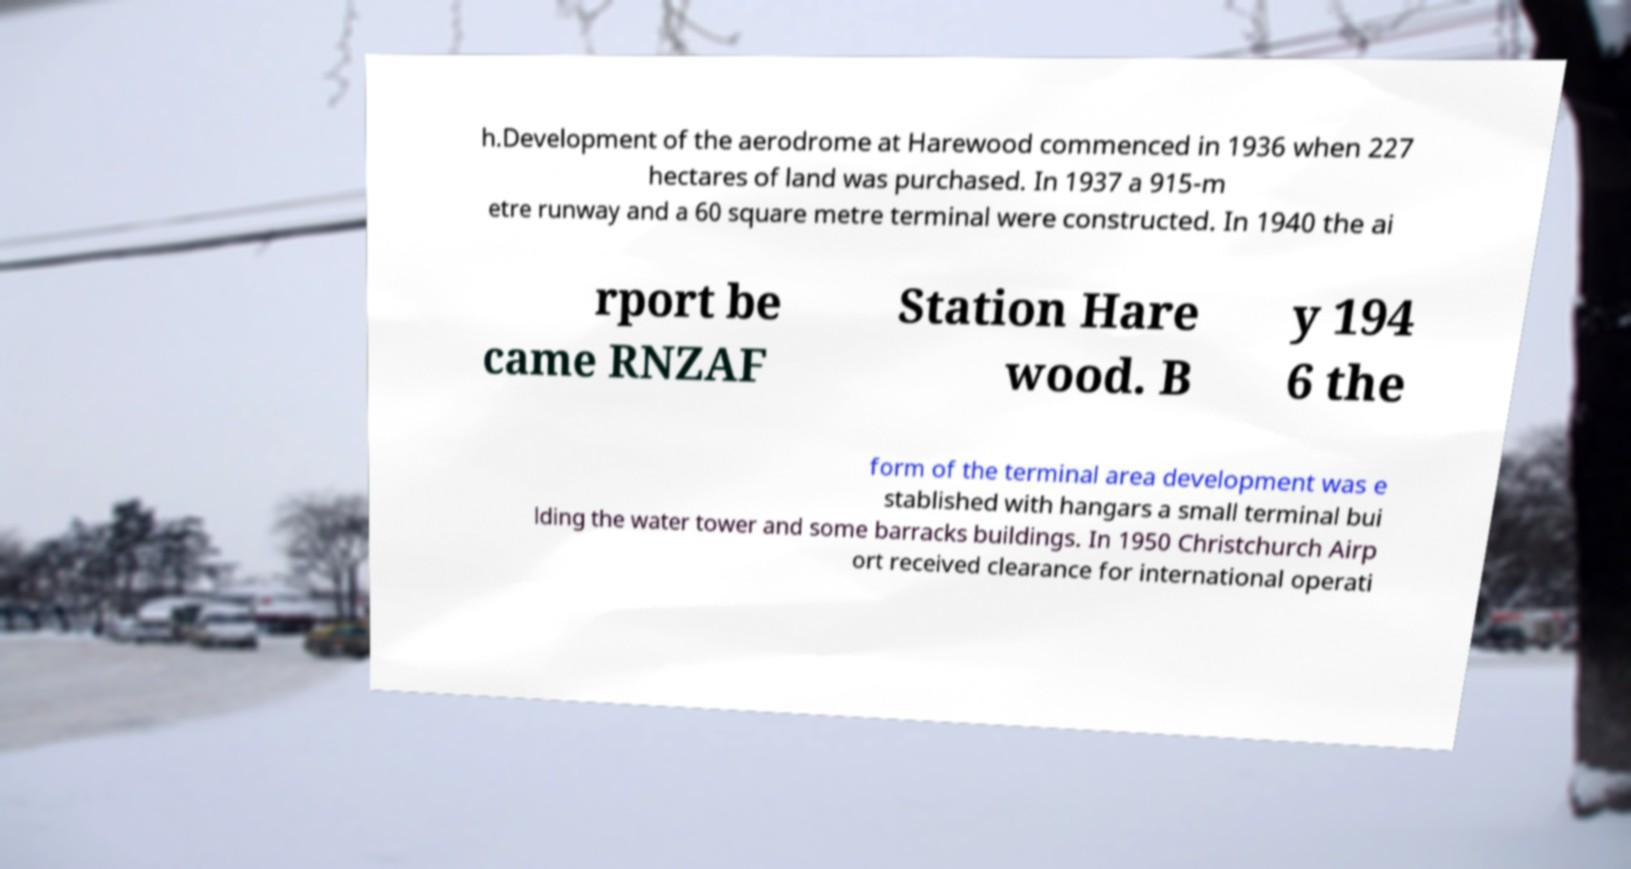Could you extract and type out the text from this image? h.Development of the aerodrome at Harewood commenced in 1936 when 227 hectares of land was purchased. In 1937 a 915-m etre runway and a 60 square metre terminal were constructed. In 1940 the ai rport be came RNZAF Station Hare wood. B y 194 6 the form of the terminal area development was e stablished with hangars a small terminal bui lding the water tower and some barracks buildings. In 1950 Christchurch Airp ort received clearance for international operati 